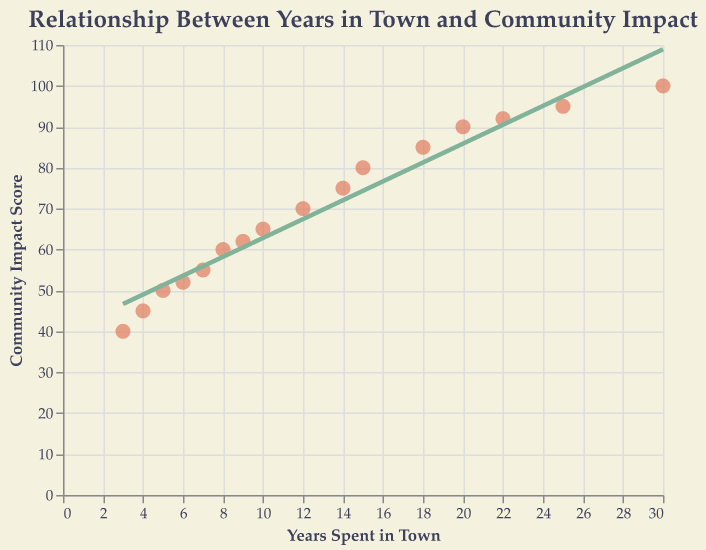What is the title of the scatter plot? The title of the figure is located at the top of the plot. It reads, "Relationship Between Years in Town and Community Impact."
Answer: Relationship Between Years in Town and Community Impact How many data points are shown in the plot? By visually counting the points, we see that there are 16 data points represented in the scatter plot.
Answer: 16 What is the color of the trend line? The trend line is distinguished by its green color, which can be observed as a single line going through the scatter plot.
Answer: Green What is the highest Community Impact Score observed in the plot, and what is the corresponding Years Spent in the Town? To find the highest score, observe the vertical axis and find the highest data point, which is at 100. The corresponding Years Spent in the Town is 30 years.
Answer: 100, 30 years Which data point has the lowest Community Impact Score, and what are its corresponding Years Spent in the Town? The lowest Community Impact Score is found at 40, which corresponds to 3 Years Spent in the Town. This can be observed by looking at the lowest point on the vertical axis.
Answer: 40, 3 years What is the overall trend observed in the relationship between Years Spent in the Town and Community Impact Score? The trend line in the scatter plot shows an upward slope, indicating a positive correlation where more years spent in the town generally result in a higher Community Impact Score.
Answer: Positive correlation What is the Community Impact Score corresponding to 10 years spent in the town according to the data points? Observing the scatter plot, we can see that the data point corresponding to 10 years has a Community Impact Score of 65.
Answer: 65 How does the Community Impact Score for 20 years spent in the town compare to that for 15 years? By looking at the scatter plot, the Community Impact Score for 20 years is 90, and for 15 years, it is 80. By comparing, 90 is greater than 80.
Answer: 90 is greater than 80 What is the average Community Impact Score for data points corresponding to less than 10 years spent in the town? The relevant data points are: 5 years (50), 3 years (40), 7 years (55), 8 years (60), 6 years (52), 4 years (45). The average is calculated as (50 + 40 + 55 + 60 + 52 + 45) / 6 = 50.33.
Answer: 50.33 What can you infer about the community impact of inhabitants who have spent 30 years in the town compared to those who spent 25 years? Observing the highest and second-highest data points, we see that 30 years has a Community Impact Score of 100, whereas 25 years has a score of 95. We can infer that an additional 5 years in the town leads to a slightly higher impact score.
Answer: 30 years has a slightly higher community impact score 